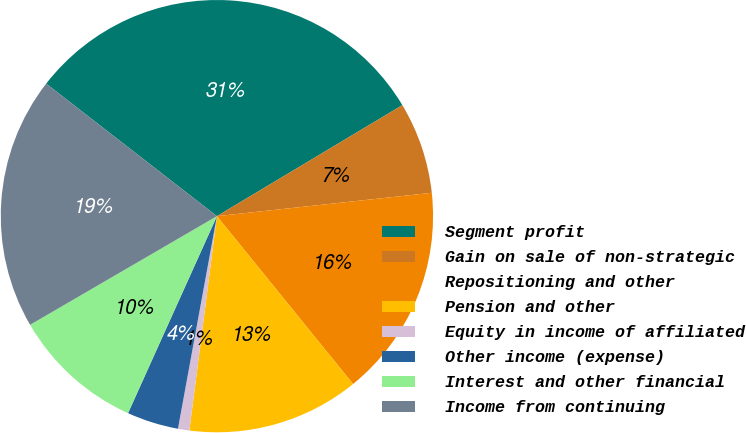Convert chart to OTSL. <chart><loc_0><loc_0><loc_500><loc_500><pie_chart><fcel>Segment profit<fcel>Gain on sale of non-strategic<fcel>Repositioning and other<fcel>Pension and other<fcel>Equity in income of affiliated<fcel>Other income (expense)<fcel>Interest and other financial<fcel>Income from continuing<nl><fcel>30.91%<fcel>6.86%<fcel>15.88%<fcel>12.88%<fcel>0.85%<fcel>3.86%<fcel>9.87%<fcel>18.89%<nl></chart> 